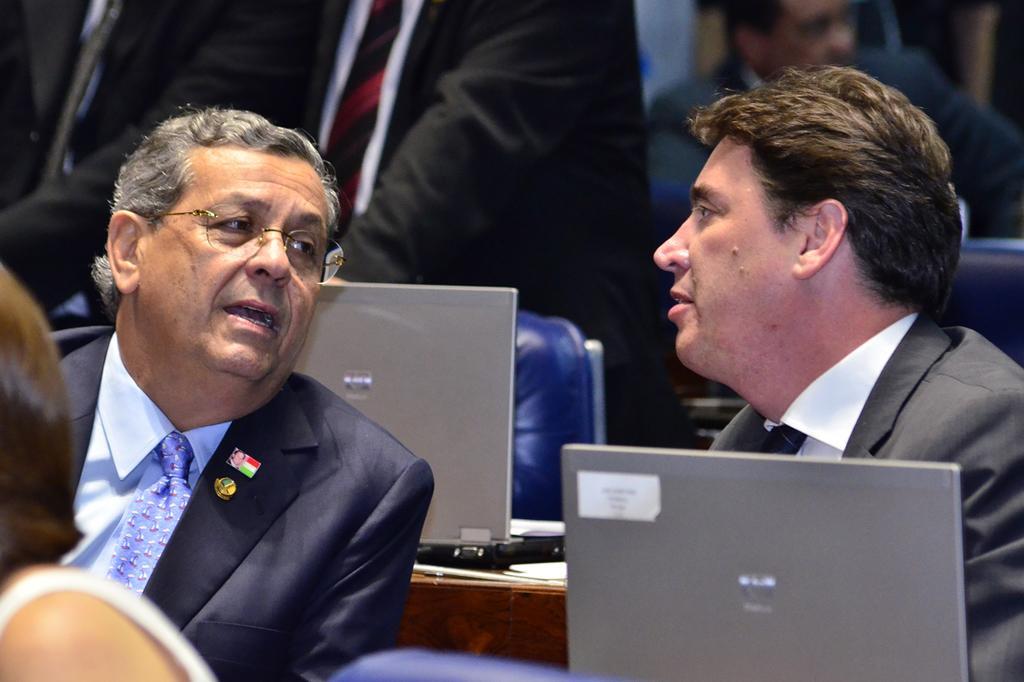Can you describe this image briefly? In this image there are two persons sitting ,there are laptops on the tables, and in the background there are group of people. 